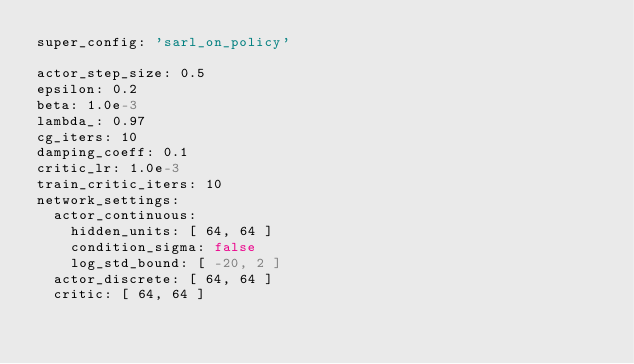<code> <loc_0><loc_0><loc_500><loc_500><_YAML_>super_config: 'sarl_on_policy'

actor_step_size: 0.5
epsilon: 0.2
beta: 1.0e-3
lambda_: 0.97
cg_iters: 10
damping_coeff: 0.1
critic_lr: 1.0e-3
train_critic_iters: 10
network_settings:
  actor_continuous:
    hidden_units: [ 64, 64 ]
    condition_sigma: false
    log_std_bound: [ -20, 2 ]
  actor_discrete: [ 64, 64 ]
  critic: [ 64, 64 ]</code> 